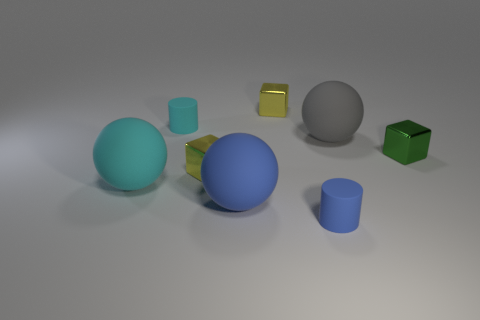Subtract all big gray balls. How many balls are left? 2 Subtract 1 spheres. How many spheres are left? 2 Subtract all green cubes. How many cubes are left? 2 Add 1 gray objects. How many objects exist? 9 Subtract all gray blocks. Subtract all purple cylinders. How many blocks are left? 3 Subtract all purple cylinders. How many yellow blocks are left? 2 Subtract all balls. Subtract all gray matte spheres. How many objects are left? 4 Add 7 cyan matte cylinders. How many cyan matte cylinders are left? 8 Add 4 rubber spheres. How many rubber spheres exist? 7 Subtract 1 cyan balls. How many objects are left? 7 